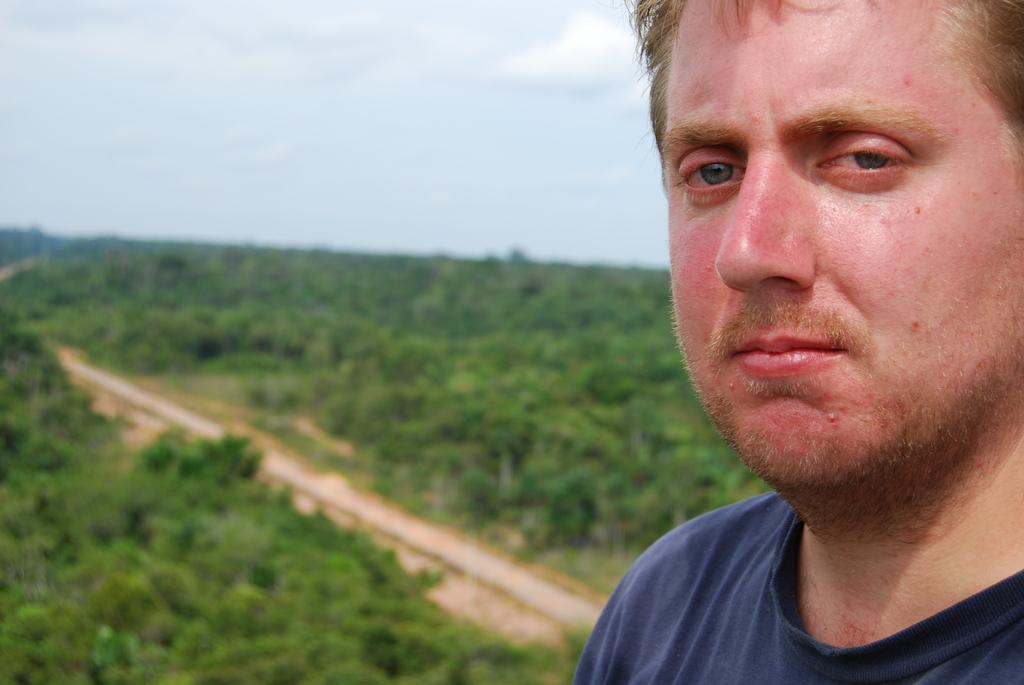Who is present in the image? There is a man in the image. What is the man wearing? The man is wearing a t-shirt. What can be seen in the background of the image? There are trees and a path visible in the background of the image. What part of the natural environment is visible in the image? The sky is visible in the image. What type of cover does the man use to protect himself from the porter in the image? There is no mention of a cover or a porter in the image; the man is simply wearing a t-shirt and standing in front of trees and a path. 